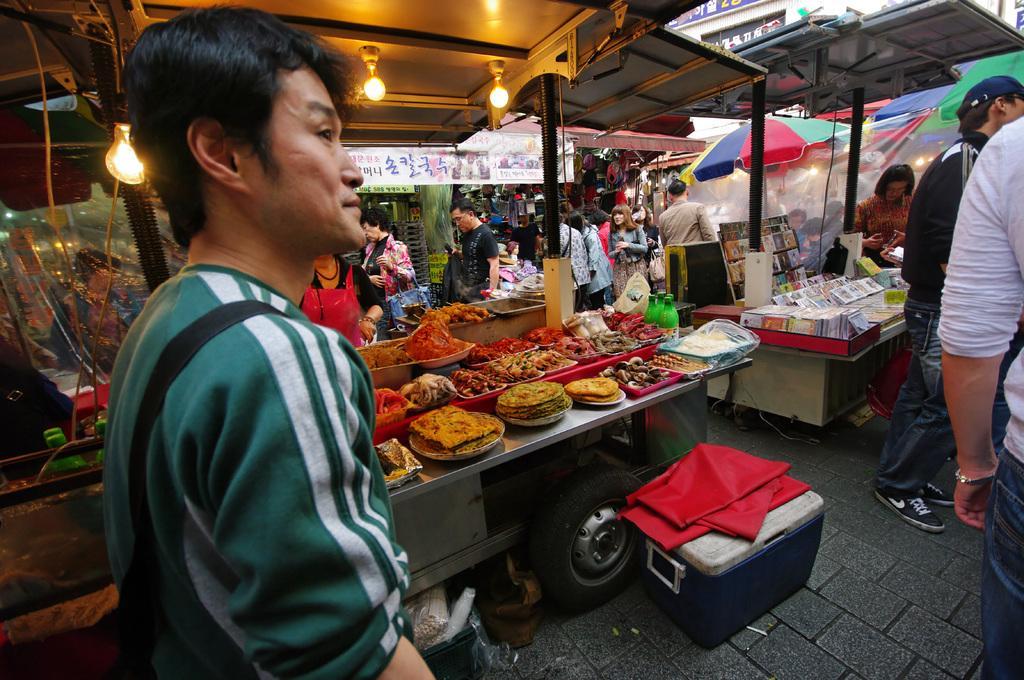Please provide a concise description of this image. In this picture we can see some people are standing and on the path there is a plastic container with a cloth. Behind the container there are vehicles with some food items and some objects. Behind the vehicles there are shops and banners. 